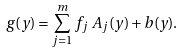Convert formula to latex. <formula><loc_0><loc_0><loc_500><loc_500>g ( y ) = \sum _ { j = 1 } ^ { m } f _ { j } \, A _ { j } ( y ) + b ( y ) .</formula> 